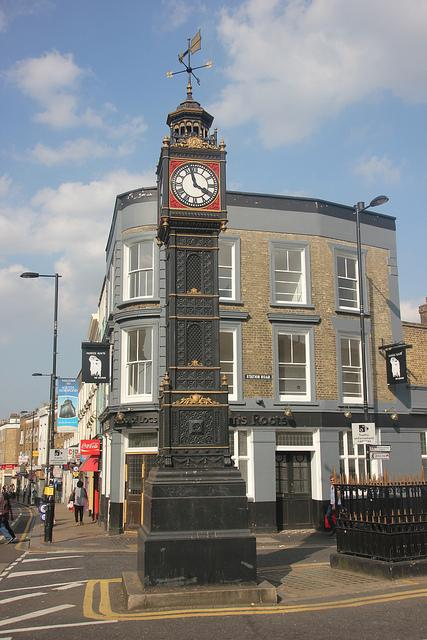This street is located where? Please explain your reasoning. city. The area is full of tall buildings and pavement. there is no grass or sand. 